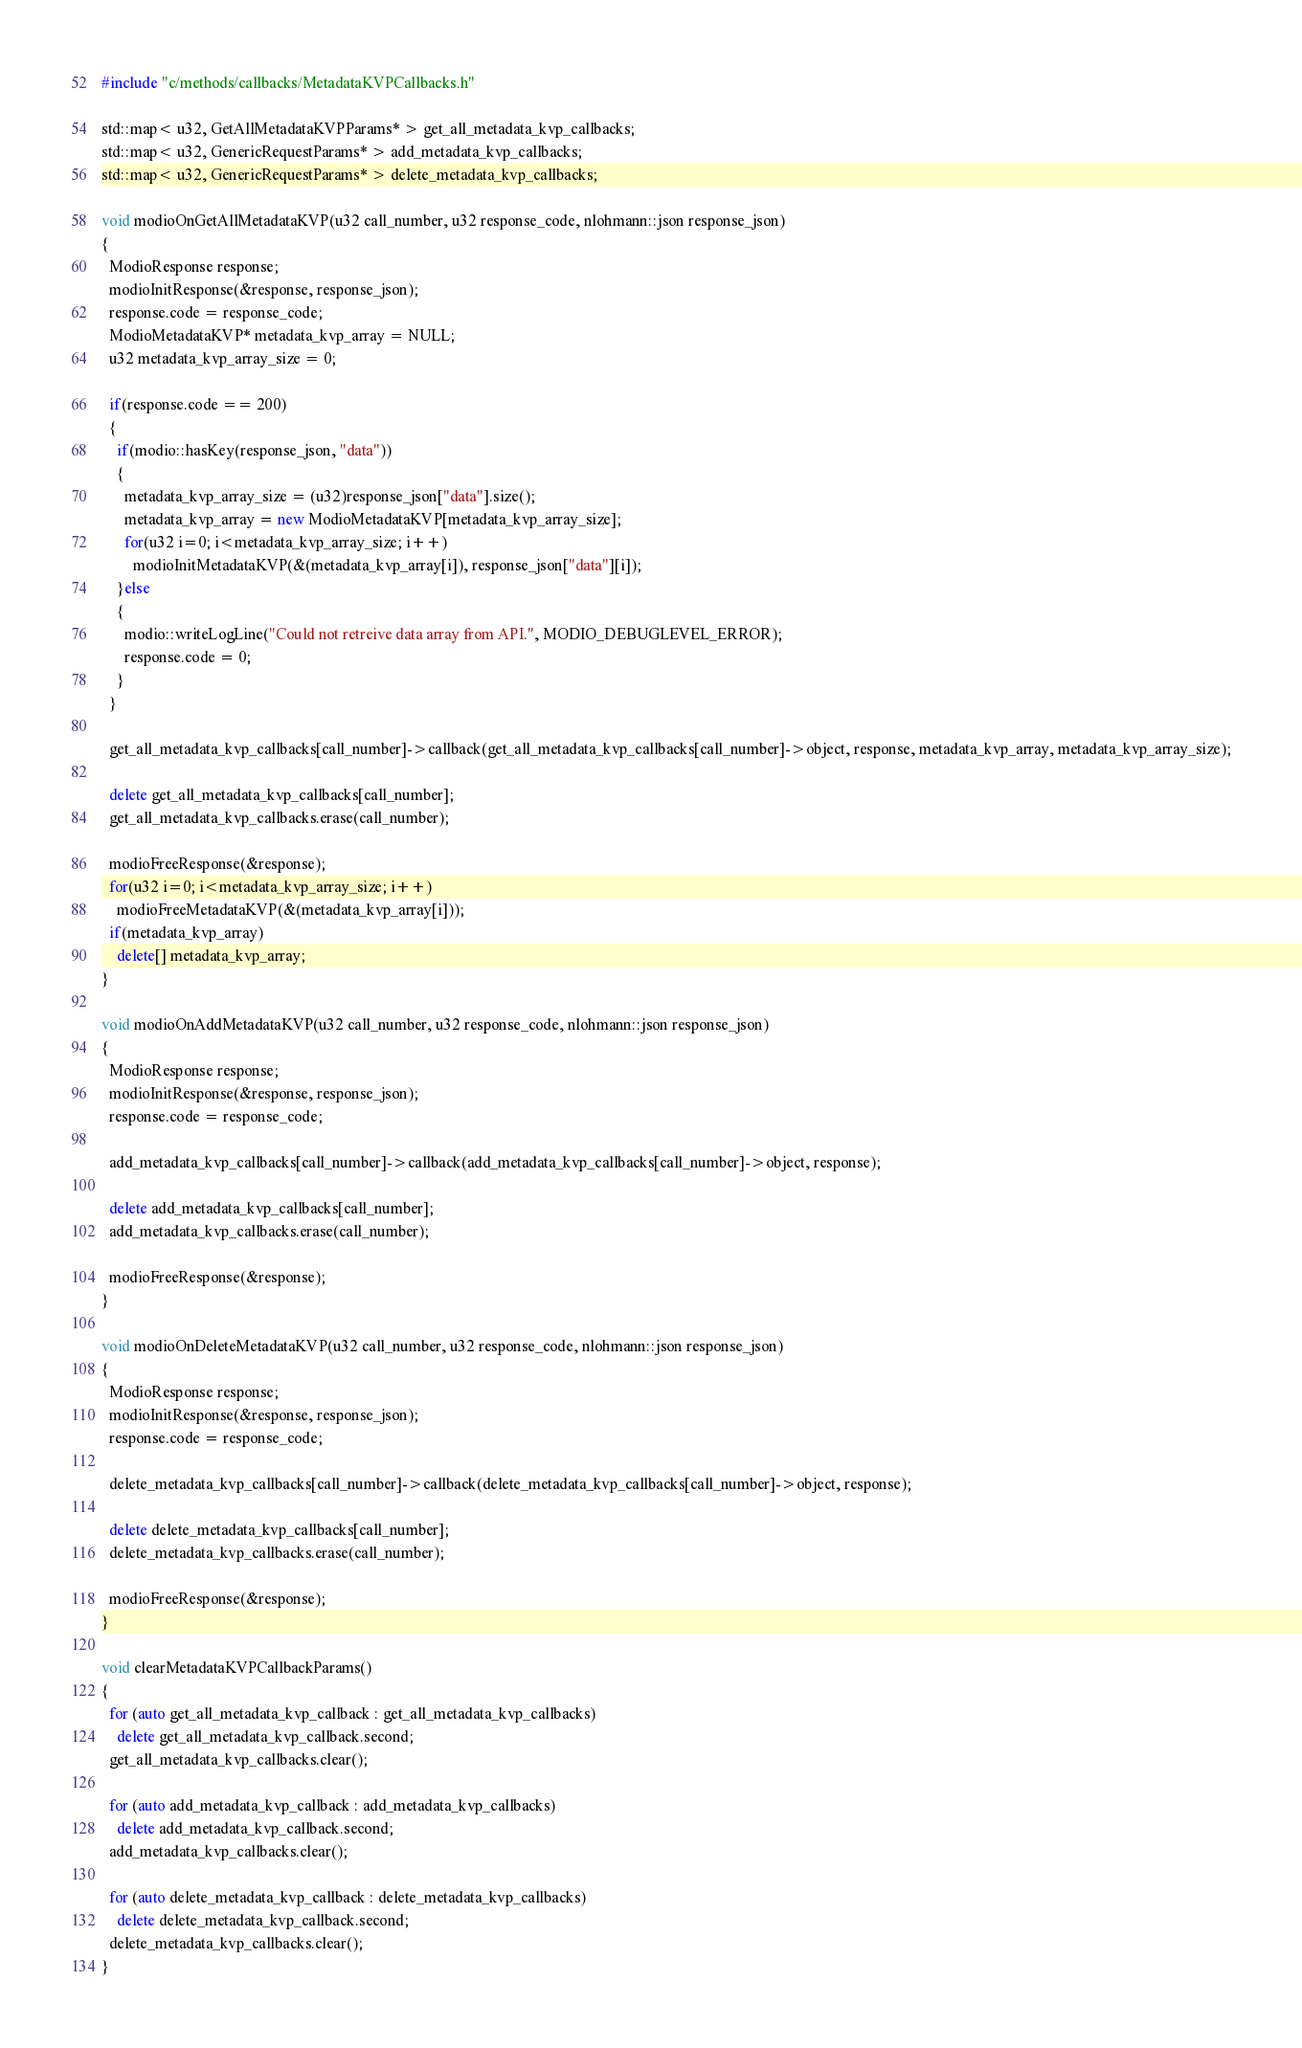<code> <loc_0><loc_0><loc_500><loc_500><_C++_>#include "c/methods/callbacks/MetadataKVPCallbacks.h"

std::map< u32, GetAllMetadataKVPParams* > get_all_metadata_kvp_callbacks;
std::map< u32, GenericRequestParams* > add_metadata_kvp_callbacks;
std::map< u32, GenericRequestParams* > delete_metadata_kvp_callbacks;

void modioOnGetAllMetadataKVP(u32 call_number, u32 response_code, nlohmann::json response_json)
{
  ModioResponse response;
  modioInitResponse(&response, response_json);
  response.code = response_code;
  ModioMetadataKVP* metadata_kvp_array = NULL;
  u32 metadata_kvp_array_size = 0;

  if(response.code == 200)
  {
    if(modio::hasKey(response_json, "data"))
    {
      metadata_kvp_array_size = (u32)response_json["data"].size();
      metadata_kvp_array = new ModioMetadataKVP[metadata_kvp_array_size];
      for(u32 i=0; i<metadata_kvp_array_size; i++)
        modioInitMetadataKVP(&(metadata_kvp_array[i]), response_json["data"][i]);
    }else
    {
      modio::writeLogLine("Could not retreive data array from API.", MODIO_DEBUGLEVEL_ERROR);
      response.code = 0;
    }
  }

  get_all_metadata_kvp_callbacks[call_number]->callback(get_all_metadata_kvp_callbacks[call_number]->object, response, metadata_kvp_array, metadata_kvp_array_size);
  
  delete get_all_metadata_kvp_callbacks[call_number];
  get_all_metadata_kvp_callbacks.erase(call_number);
  
  modioFreeResponse(&response);
  for(u32 i=0; i<metadata_kvp_array_size; i++)
    modioFreeMetadataKVP(&(metadata_kvp_array[i]));
  if(metadata_kvp_array)
    delete[] metadata_kvp_array;
}

void modioOnAddMetadataKVP(u32 call_number, u32 response_code, nlohmann::json response_json)
{
  ModioResponse response;
  modioInitResponse(&response, response_json);
  response.code = response_code;

  add_metadata_kvp_callbacks[call_number]->callback(add_metadata_kvp_callbacks[call_number]->object, response);
  
  delete add_metadata_kvp_callbacks[call_number];
  add_metadata_kvp_callbacks.erase(call_number);
  
  modioFreeResponse(&response);
}

void modioOnDeleteMetadataKVP(u32 call_number, u32 response_code, nlohmann::json response_json)
{
  ModioResponse response;
  modioInitResponse(&response, response_json);
  response.code = response_code;

  delete_metadata_kvp_callbacks[call_number]->callback(delete_metadata_kvp_callbacks[call_number]->object, response);
  
  delete delete_metadata_kvp_callbacks[call_number];
  delete_metadata_kvp_callbacks.erase(call_number);
  
  modioFreeResponse(&response);
}

void clearMetadataKVPCallbackParams()
{
  for (auto get_all_metadata_kvp_callback : get_all_metadata_kvp_callbacks)
    delete get_all_metadata_kvp_callback.second;
  get_all_metadata_kvp_callbacks.clear();

  for (auto add_metadata_kvp_callback : add_metadata_kvp_callbacks)
    delete add_metadata_kvp_callback.second;
  add_metadata_kvp_callbacks.clear();

  for (auto delete_metadata_kvp_callback : delete_metadata_kvp_callbacks)
    delete delete_metadata_kvp_callback.second;
  delete_metadata_kvp_callbacks.clear();
}</code> 